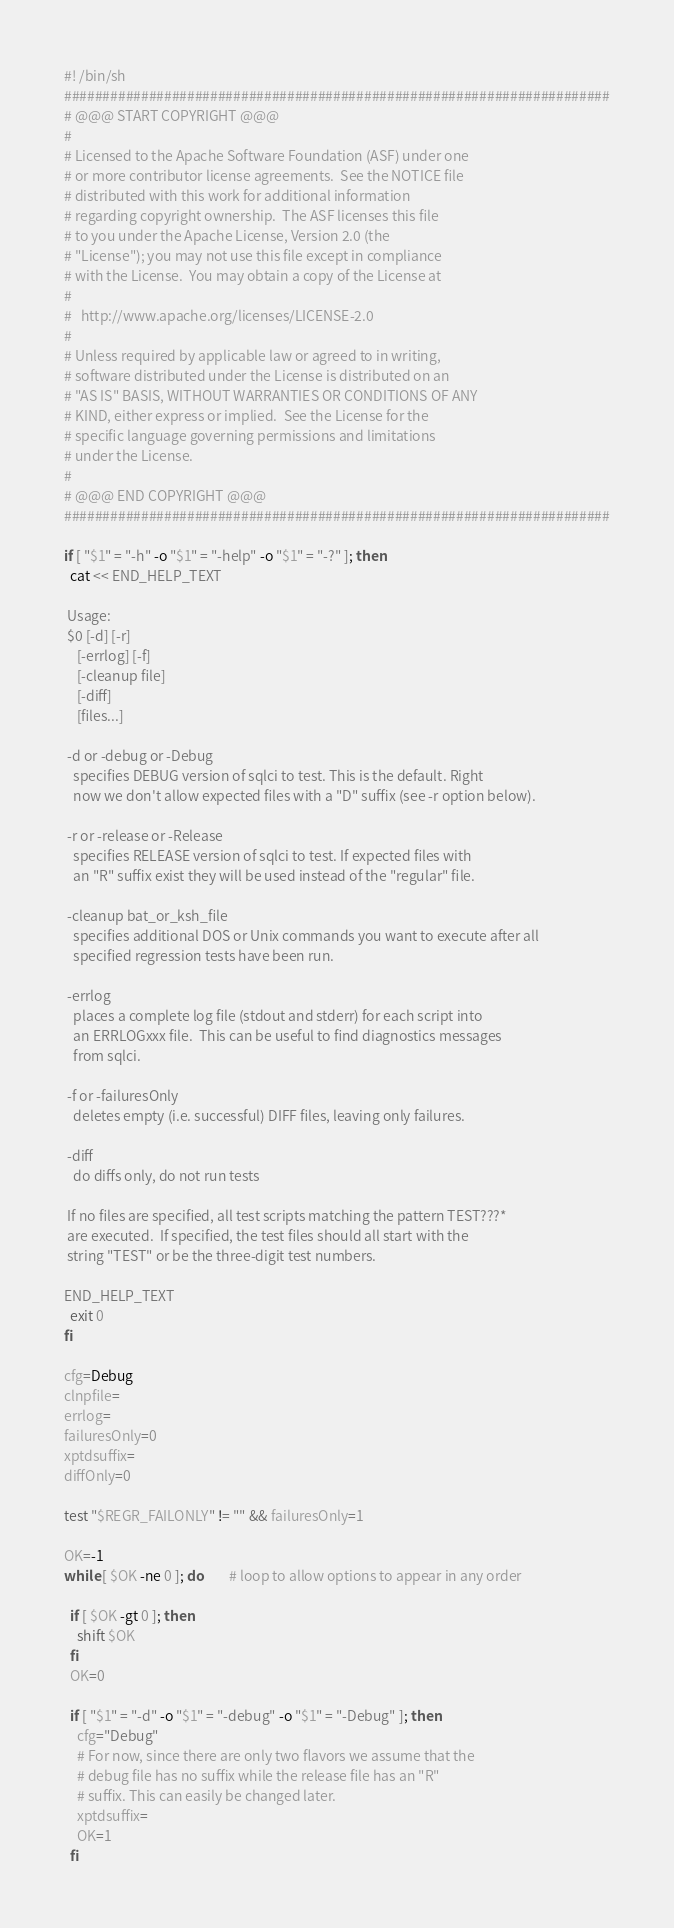<code> <loc_0><loc_0><loc_500><loc_500><_Bash_>#! /bin/sh
#######################################################################
# @@@ START COPYRIGHT @@@
#
# Licensed to the Apache Software Foundation (ASF) under one
# or more contributor license agreements.  See the NOTICE file
# distributed with this work for additional information
# regarding copyright ownership.  The ASF licenses this file
# to you under the Apache License, Version 2.0 (the
# "License"); you may not use this file except in compliance
# with the License.  You may obtain a copy of the License at
#
#   http://www.apache.org/licenses/LICENSE-2.0
#
# Unless required by applicable law or agreed to in writing,
# software distributed under the License is distributed on an
# "AS IS" BASIS, WITHOUT WARRANTIES OR CONDITIONS OF ANY
# KIND, either express or implied.  See the License for the
# specific language governing permissions and limitations
# under the License.
#
# @@@ END COPYRIGHT @@@
#######################################################################

if [ "$1" = "-h" -o "$1" = "-help" -o "$1" = "-?" ]; then
  cat << END_HELP_TEXT

 Usage:
 $0 [-d] [-r]
    [-errlog] [-f]
    [-cleanup file]
    [-diff] 
    [files...]

 -d or -debug or -Debug
   specifies DEBUG version of sqlci to test. This is the default. Right
   now we don't allow expected files with a "D" suffix (see -r option below).

 -r or -release or -Release
   specifies RELEASE version of sqlci to test. If expected files with
   an "R" suffix exist they will be used instead of the "regular" file.

 -cleanup bat_or_ksh_file
   specifies additional DOS or Unix commands you want to execute after all
   specified regression tests have been run.

 -errlog
   places a complete log file (stdout and stderr) for each script into
   an ERRLOGxxx file.  This can be useful to find diagnostics messages
   from sqlci.

 -f or -failuresOnly
   deletes empty (i.e. successful) DIFF files, leaving only failures.

 -diff
   do diffs only, do not run tests

 If no files are specified, all test scripts matching the pattern TEST???*
 are executed.  If specified, the test files should all start with the
 string "TEST" or be the three-digit test numbers.

END_HELP_TEXT
  exit 0
fi

cfg=Debug
clnpfile=
errlog=
failuresOnly=0
xptdsuffix=
diffOnly=0

test "$REGR_FAILONLY" != "" && failuresOnly=1

OK=-1
while [ $OK -ne 0 ]; do		# loop to allow options to appear in any order

  if [ $OK -gt 0 ]; then
    shift $OK
  fi
  OK=0

  if [ "$1" = "-d" -o "$1" = "-debug" -o "$1" = "-Debug" ]; then
    cfg="Debug"
    # For now, since there are only two flavors we assume that the
    # debug file has no suffix while the release file has an "R"
    # suffix. This can easily be changed later.
    xptdsuffix=
    OK=1
  fi
</code> 